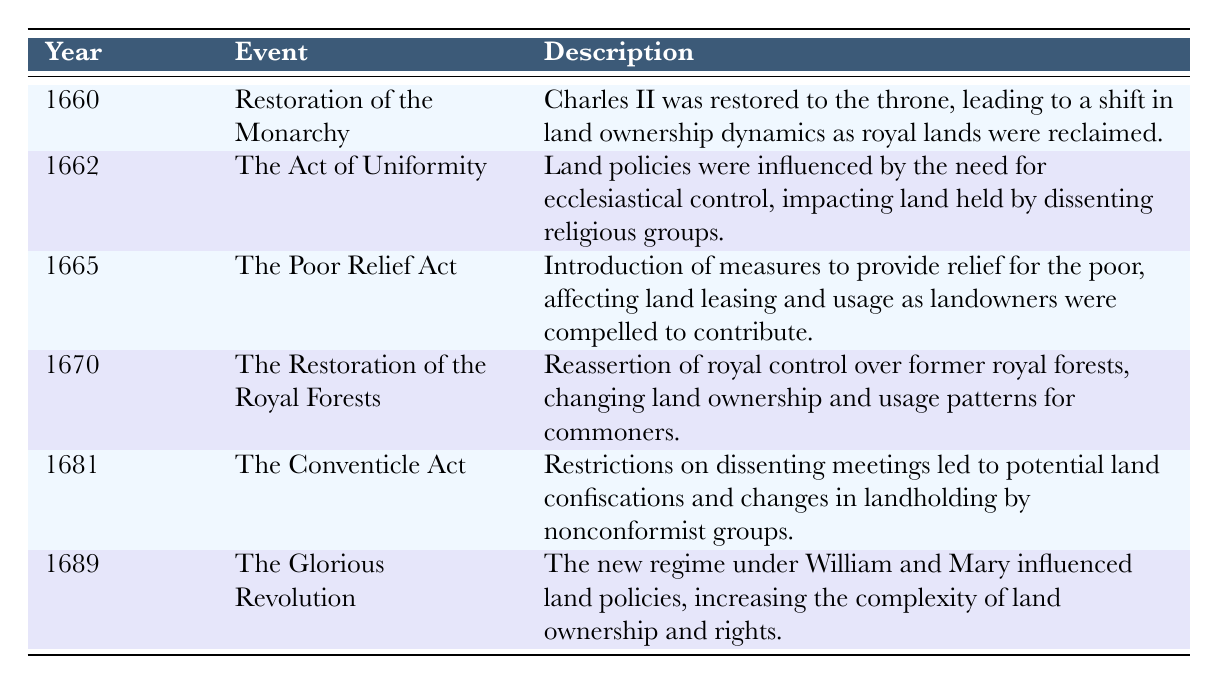What event occurred in 1662 that influenced land policies? The table indicates that in 1662, "The Act of Uniformity" occurred, which influenced land policies by impacting land held by dissenting religious groups.
Answer: The Act of Uniformity Which year saw the introduction of the Poor Relief Act? From the table, the Poor Relief Act was introduced in 1665, which is clearly stated in the corresponding row.
Answer: 1665 Did the Glorious Revolution occur before or after the Restoration of the Royal Forests? The Glorious Revolution occurred in 1689, while the Restoration of the Royal Forests occurred in 1670. Since 1689 is after 1670, the answer is clearly "after."
Answer: After How many events listed in the table are specifically related to changes in land ownership? The events related to changes in land ownership are the Restoration of the Monarchy (1660) and the Restoration of the Royal Forests (1670). By counting these, we find there are two events specifically related to land ownership.
Answer: 2 Which event in 1681 could potentially lead to land confiscations for nonconformist groups? The table states that the Conventicle Act in 1681 imposed restrictions on dissenting meetings, which led to potential land confiscations for nonconformist groups. This directly addresses the question of potential land confiscation.
Answer: The Conventicle Act Considering the years 1660 and 1689, which event reflects a shift in land ownership dynamics due to a change in monarchy? The Restoration of the Monarchy in 1660 led to a shift in land ownership dynamics, whereas the Glorious Revolution in 1689 influenced complexity in land ownership, but the first event is more directly about a monarchy change impacting land.
Answer: Restoration of the Monarchy Was there an event in 1665 that impacted land leasing and usage? Yes, the Poor Relief Act in 1665 introduced measures for poor relief, affecting land leasing and usage as outlined in the table. This makes the answer clear as "yes."
Answer: Yes What was the effect of the Act of Uniformity on land held by dissenting groups? According to the table, the Act of Uniformity impacted land held by dissenting religious groups due to the need for ecclesiastical control influencing land policies.
Answer: Ecclesiastical control Identify the trend regarding land policy changes from 1660 to 1689 based on the table. Analyzing the events from the table, the trend shows a gradual increase in restrictions and complexities surrounding land ownership and rights as different monarchy changes occurred, starting with royal reclamation and ending with the complexities under William and Mary.
Answer: Increased restrictions and complexities 